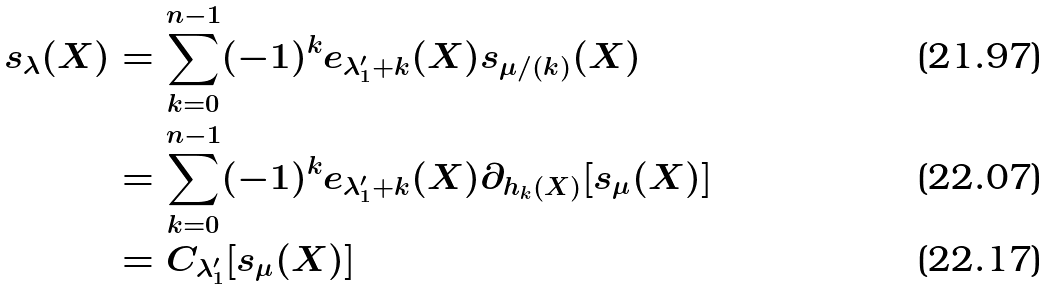<formula> <loc_0><loc_0><loc_500><loc_500>s _ { \lambda } ( X ) & = \sum _ { k = 0 } ^ { n - 1 } ( - 1 ) ^ { k } e _ { \lambda ^ { \prime } _ { 1 } + k } ( X ) s _ { \mu / ( k ) } ( X ) \\ & = \sum _ { k = 0 } ^ { n - 1 } ( - 1 ) ^ { k } e _ { \lambda ^ { \prime } _ { 1 } + k } ( X ) \partial _ { h _ { k } ( X ) } [ s _ { \mu } ( X ) ] \\ & = C _ { \lambda _ { 1 } ^ { \prime } } [ s _ { \mu } ( X ) ]</formula> 